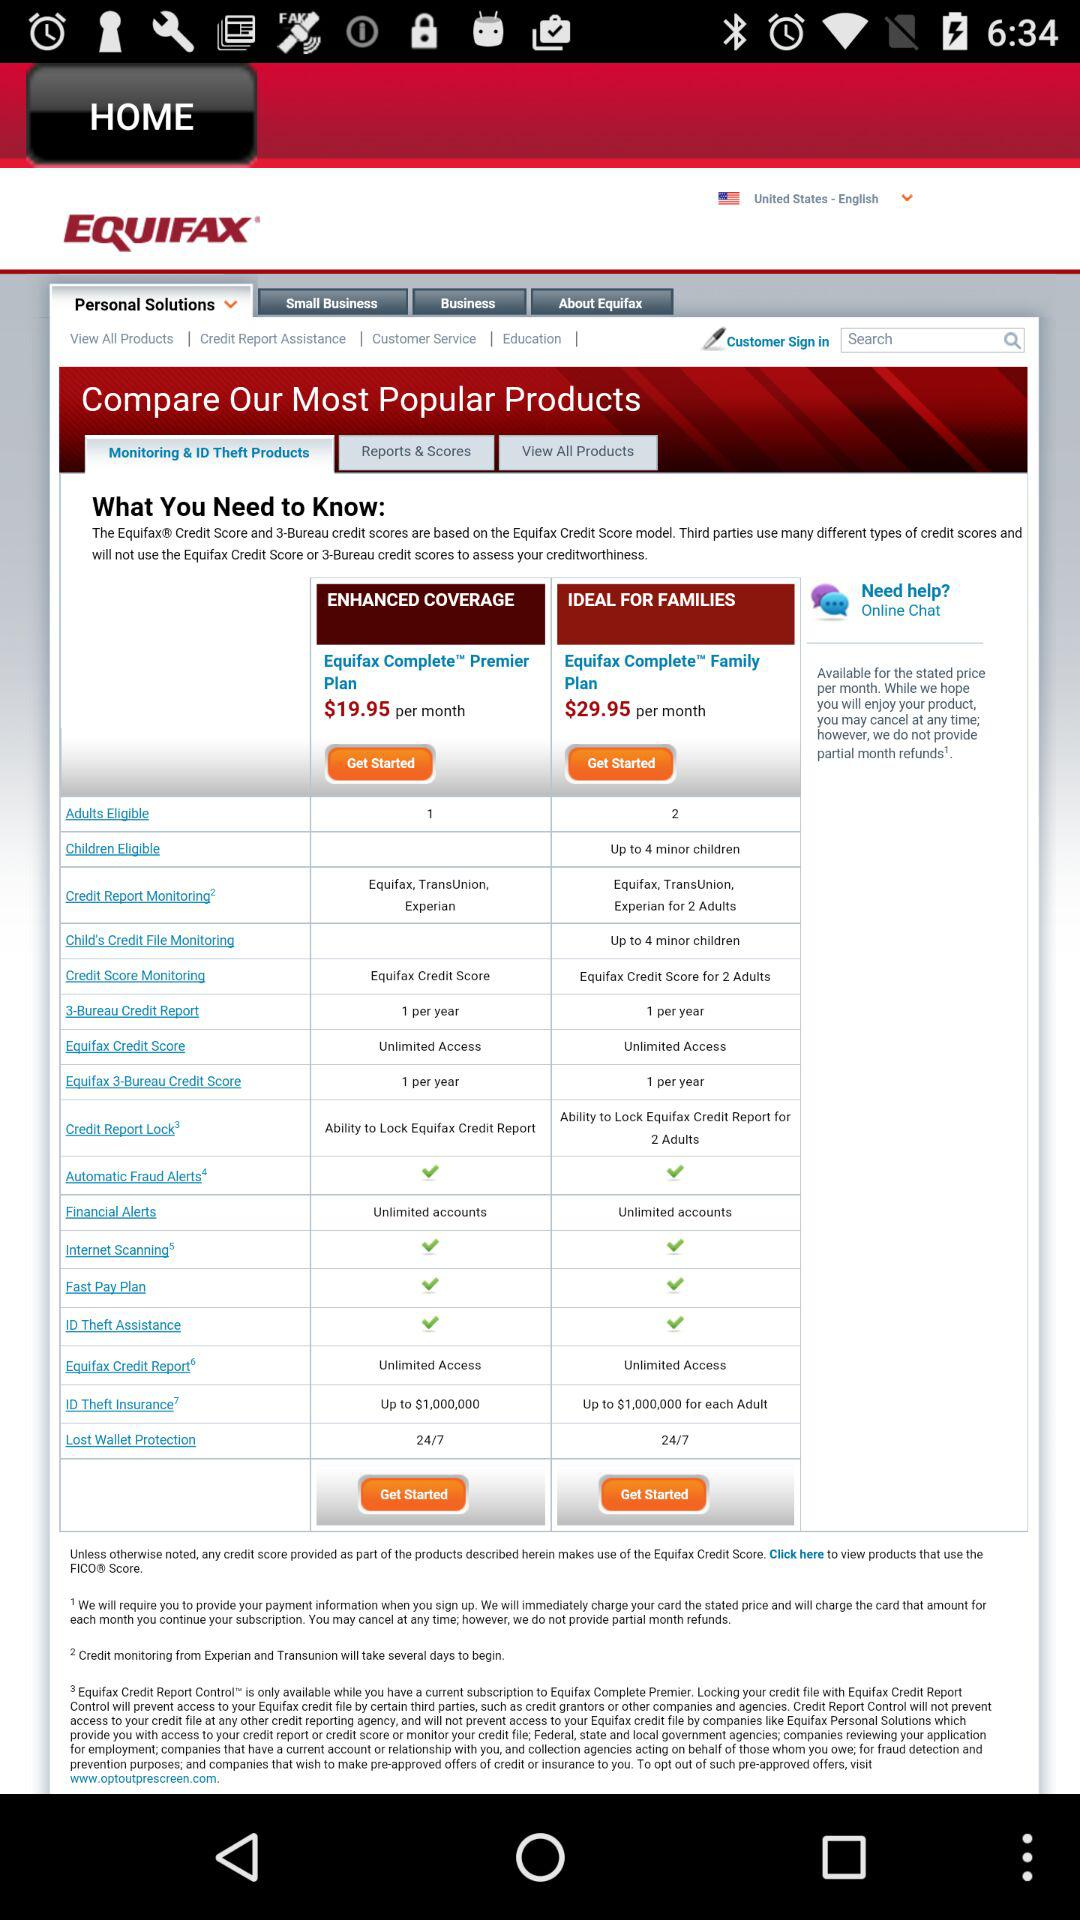What is Equifax?
When the provided information is insufficient, respond with <no answer>. <no answer> 